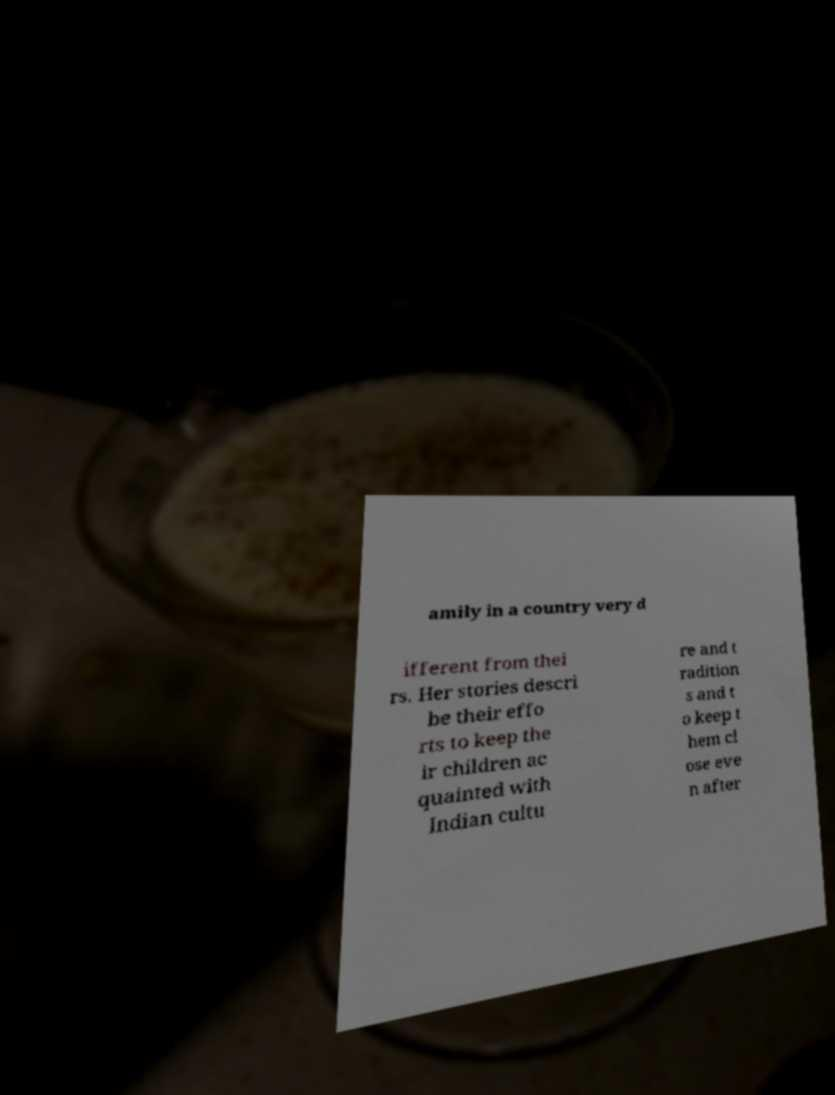Could you assist in decoding the text presented in this image and type it out clearly? amily in a country very d ifferent from thei rs. Her stories descri be their effo rts to keep the ir children ac quainted with Indian cultu re and t radition s and t o keep t hem cl ose eve n after 